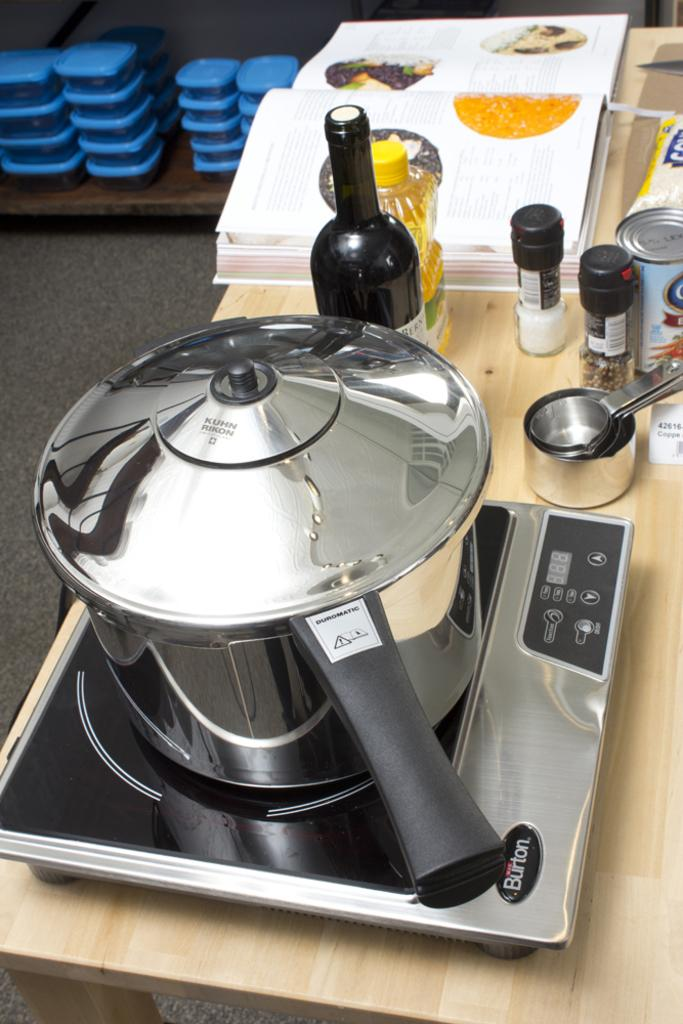<image>
Offer a succinct explanation of the picture presented. A Duromatic pressure cooker sits on a burner near some ingredients and an open recipe book. 